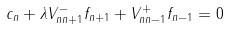<formula> <loc_0><loc_0><loc_500><loc_500>c _ { n } + \lambda V ^ { - } _ { n n + 1 } f _ { n + 1 } + V ^ { + } _ { n n - 1 } f _ { n - 1 } = 0 \\</formula> 